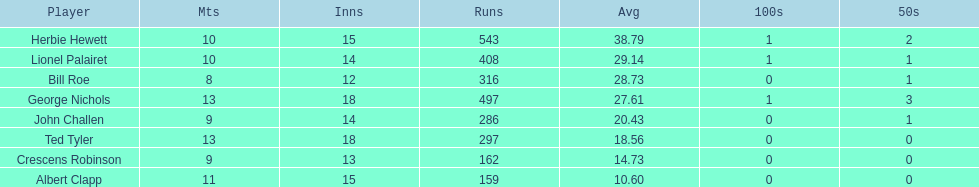Identify a player with an average exceeding 2 Herbie Hewett. 